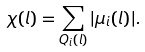<formula> <loc_0><loc_0><loc_500><loc_500>\chi ( l ) = \sum _ { Q _ { i } ( l ) } | \mu _ { i } ( l ) | .</formula> 